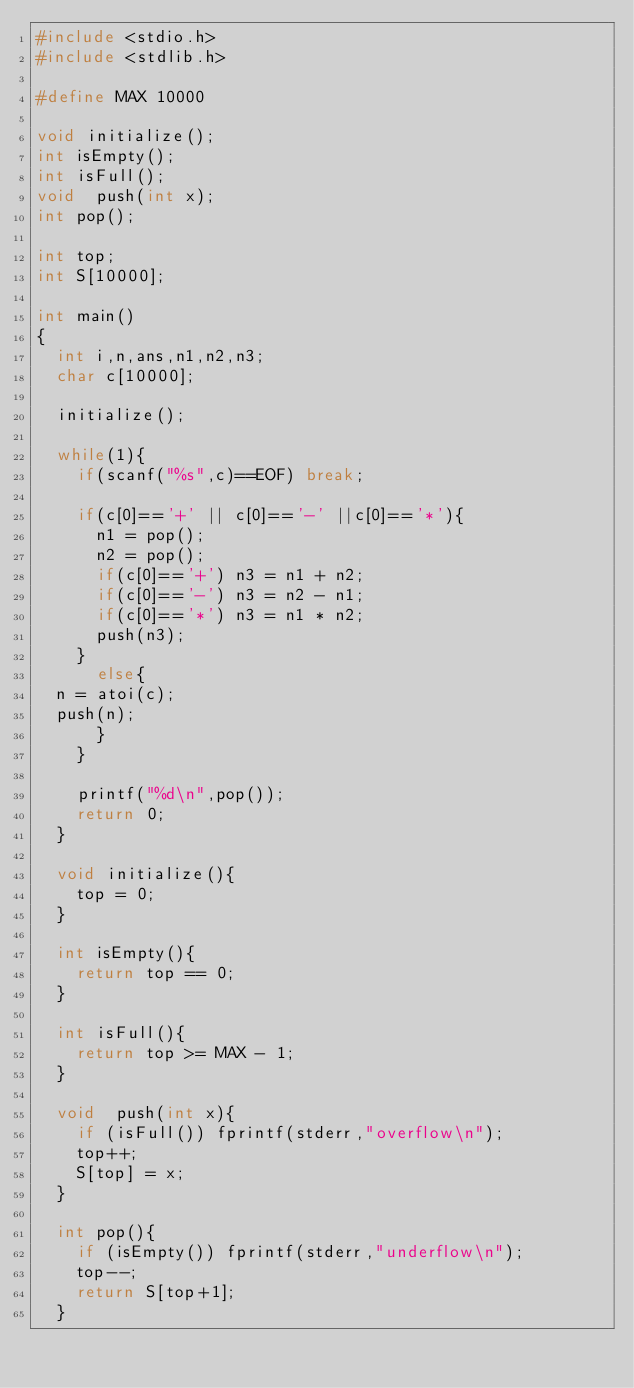<code> <loc_0><loc_0><loc_500><loc_500><_C_>#include <stdio.h>
#include <stdlib.h>

#define MAX 10000

void initialize();
int isEmpty();
int isFull();
void  push(int x);
int pop();

int top;
int S[10000];

int main()
{
  int i,n,ans,n1,n2,n3;
  char c[10000];

  initialize();

  while(1){
    if(scanf("%s",c)==EOF) break;

    if(c[0]=='+' || c[0]=='-' ||c[0]=='*'){
      n1 = pop();
      n2 = pop();
      if(c[0]=='+') n3 = n1 + n2;
      if(c[0]=='-') n3 = n2 - n1;
      if(c[0]=='*') n3 = n1 * n2;
      push(n3);
    }
      else{
	n = atoi(c);
	push(n);
      }
    }

    printf("%d\n",pop());
    return 0;
  }

  void initialize(){
    top = 0;
  }

  int isEmpty(){
    return top == 0;
  }

  int isFull(){
    return top >= MAX - 1;
  }

  void  push(int x){
    if (isFull()) fprintf(stderr,"overflow\n");
    top++;
    S[top] = x;
  }

  int pop(){
    if (isEmpty()) fprintf(stderr,"underflow\n");
    top--;
    return S[top+1];
  }</code> 